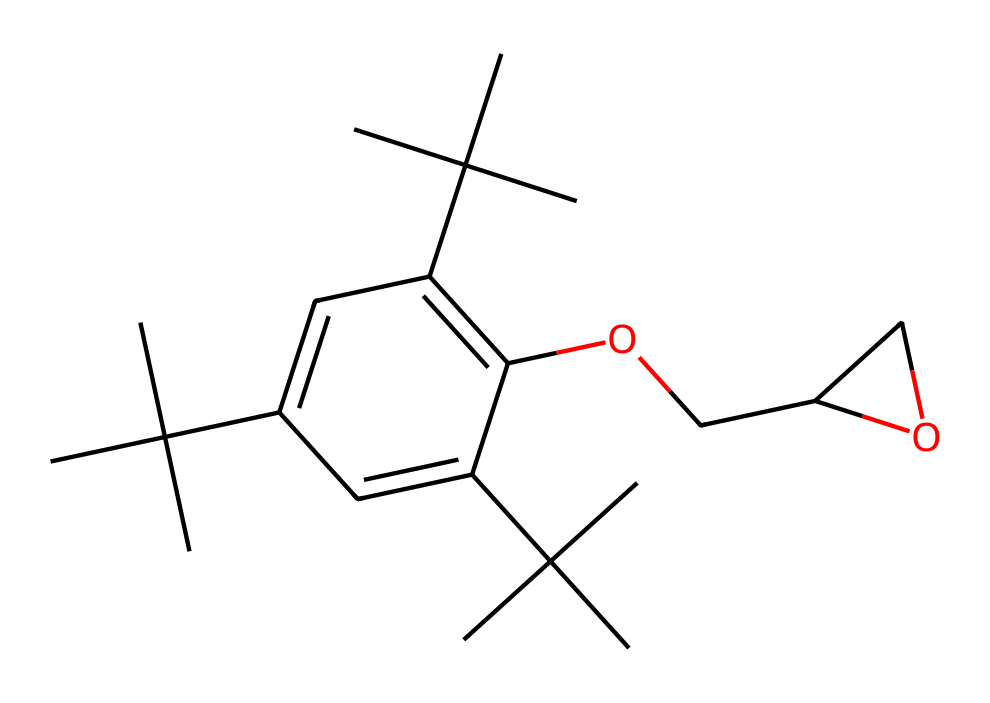what is the main functional group present in this chemical? The presence of the hydroxyl group (-OH) indicates that this chemical contains alcohol functionality, which is a key characteristic in many epoxy resin monomers.
Answer: hydroxyl group how many carbon atoms are in the structure? By counting the carbon atoms in the given SMILES representation, we find that there are 22 carbon atoms total in the structure.
Answer: 22 what type of polymer is formed from this monomer? This monomer can participate in the formation of addition polymers, commonly seen with epoxy resins where cross-linking occurs.
Answer: addition polymer what is the degree of saturation for this chemical structure? Analyzing the structure, we calculate the degree of saturation by counting rings and double bonds. This structure has a degree of saturation greater than 1 due to one double bond and at least one ring present.
Answer: greater than 1 how many oxygen atoms are present in this structure? The molecule contains two oxygen atoms, which can be identified from the structure, specifically part of the alcohol and the ether type structure.
Answer: 2 what role do branched alkyl groups play in the properties of epoxies? The branched alkyl groups contribute to the overall flexibility and impact resistance of the epoxy resin, enhancing its mechanical properties and performance in flooring applications.
Answer: flexibility and impact resistance what does the presence of the ether functionality suggest about the reactivity of this monomer? The ether functionality suggests that this monomer can undergo nucleophilic attack, which is significant in the curing process of epoxy resins, leading to robust chemical properties.
Answer: nucleophilic attack 